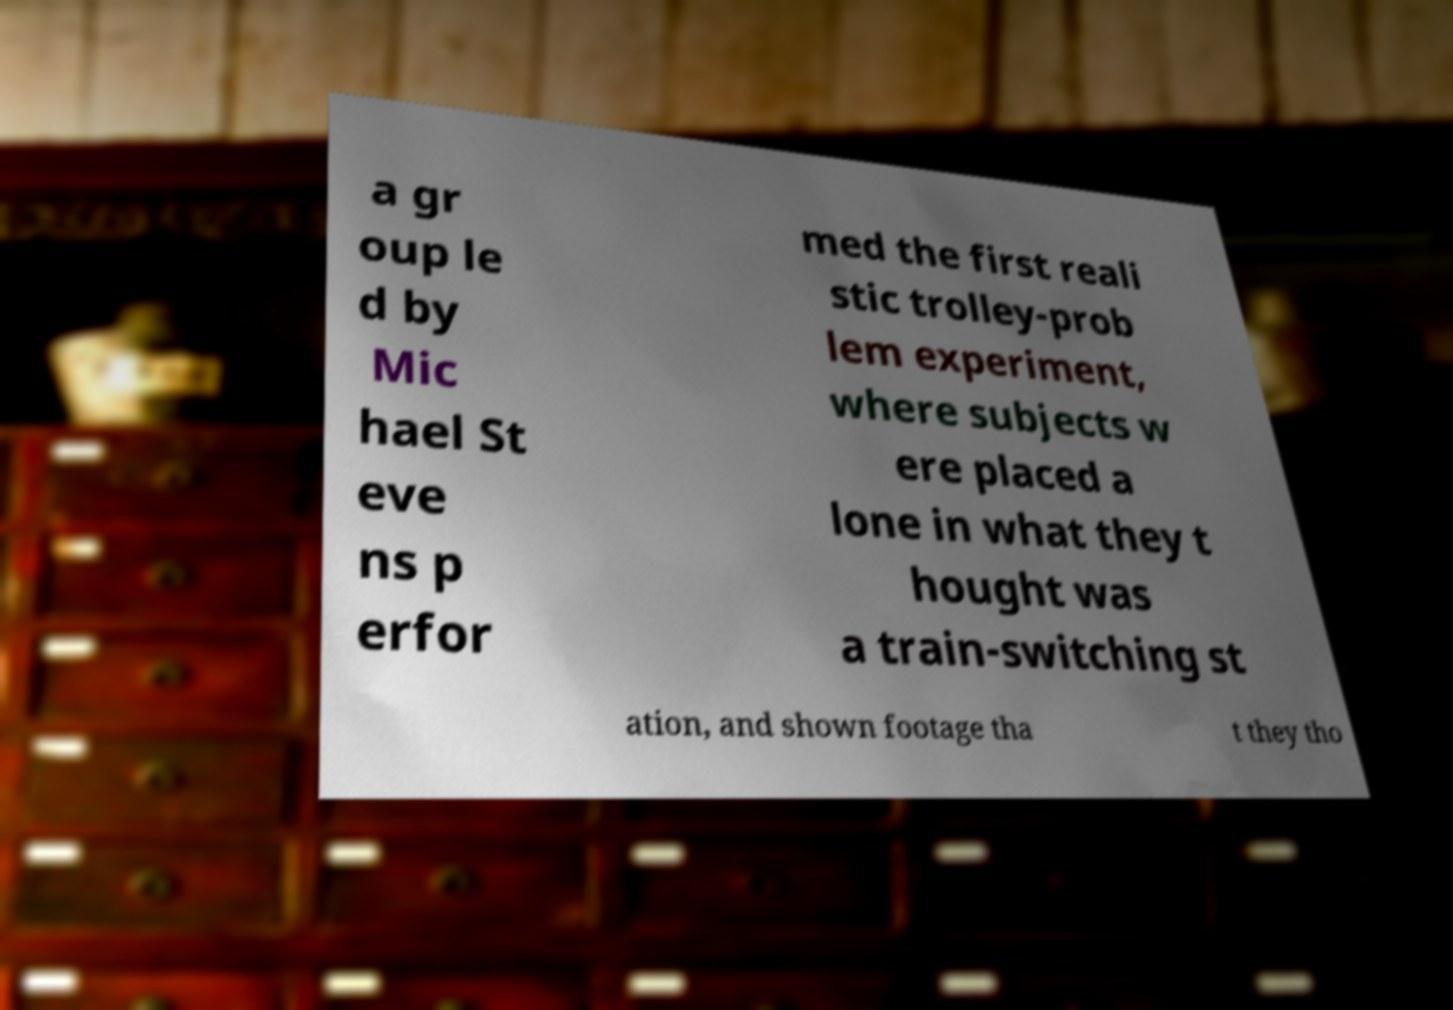Can you read and provide the text displayed in the image?This photo seems to have some interesting text. Can you extract and type it out for me? a gr oup le d by Mic hael St eve ns p erfor med the first reali stic trolley-prob lem experiment, where subjects w ere placed a lone in what they t hought was a train-switching st ation, and shown footage tha t they tho 